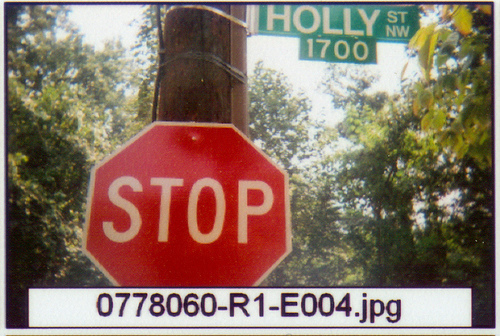Read all the text in this image. HOLLY ST NW 1700 STOP 0778060-R1-E004.jpg 